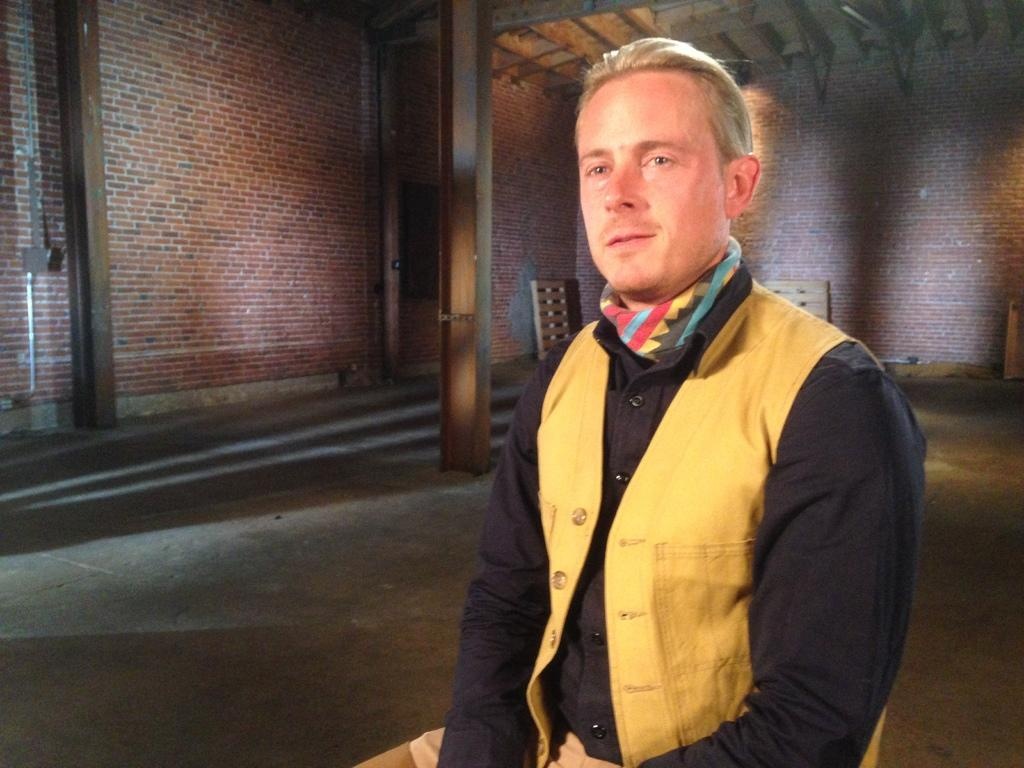What is the position of the man in the image? There is a man sitting in the front of the image. What can be seen in the background of the image? There is a brick wall in the background of the image. What is located in the middle of the image? There is a pillar in the middle of the image. How many trees are present in the image? There are no trees visible in the image. What type of impulse can be seen affecting the man in the image? There is no impulse affecting the man in the image; he is simply sitting. 